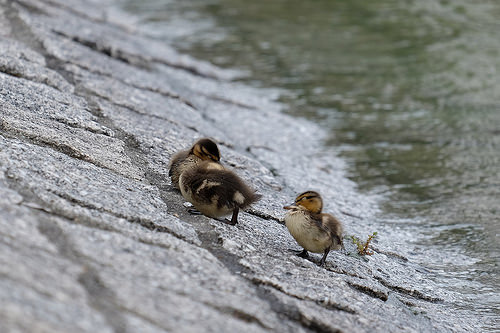<image>
Can you confirm if the duckling is under the duckling? No. The duckling is not positioned under the duckling. The vertical relationship between these objects is different. 